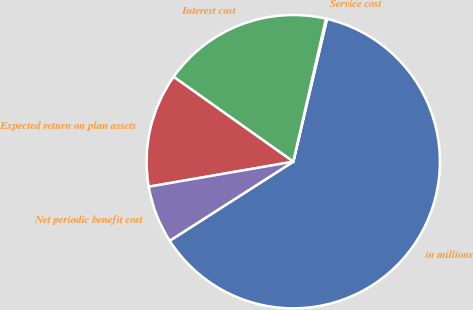Convert chart to OTSL. <chart><loc_0><loc_0><loc_500><loc_500><pie_chart><fcel>in millions<fcel>Service cost<fcel>Interest cost<fcel>Expected return on plan assets<fcel>Net periodic benefit cost<nl><fcel>62.24%<fcel>0.12%<fcel>18.76%<fcel>12.55%<fcel>6.33%<nl></chart> 